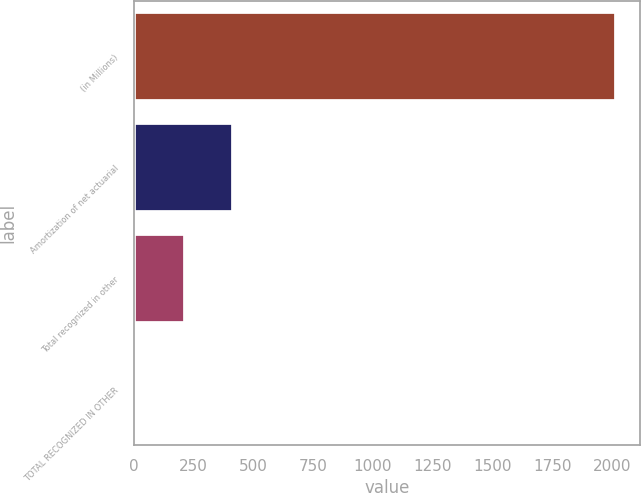<chart> <loc_0><loc_0><loc_500><loc_500><bar_chart><fcel>(in Millions)<fcel>Amortization of net actuarial<fcel>Total recognized in other<fcel>TOTAL RECOGNIZED IN OTHER<nl><fcel>2016<fcel>413.92<fcel>213.66<fcel>13.4<nl></chart> 